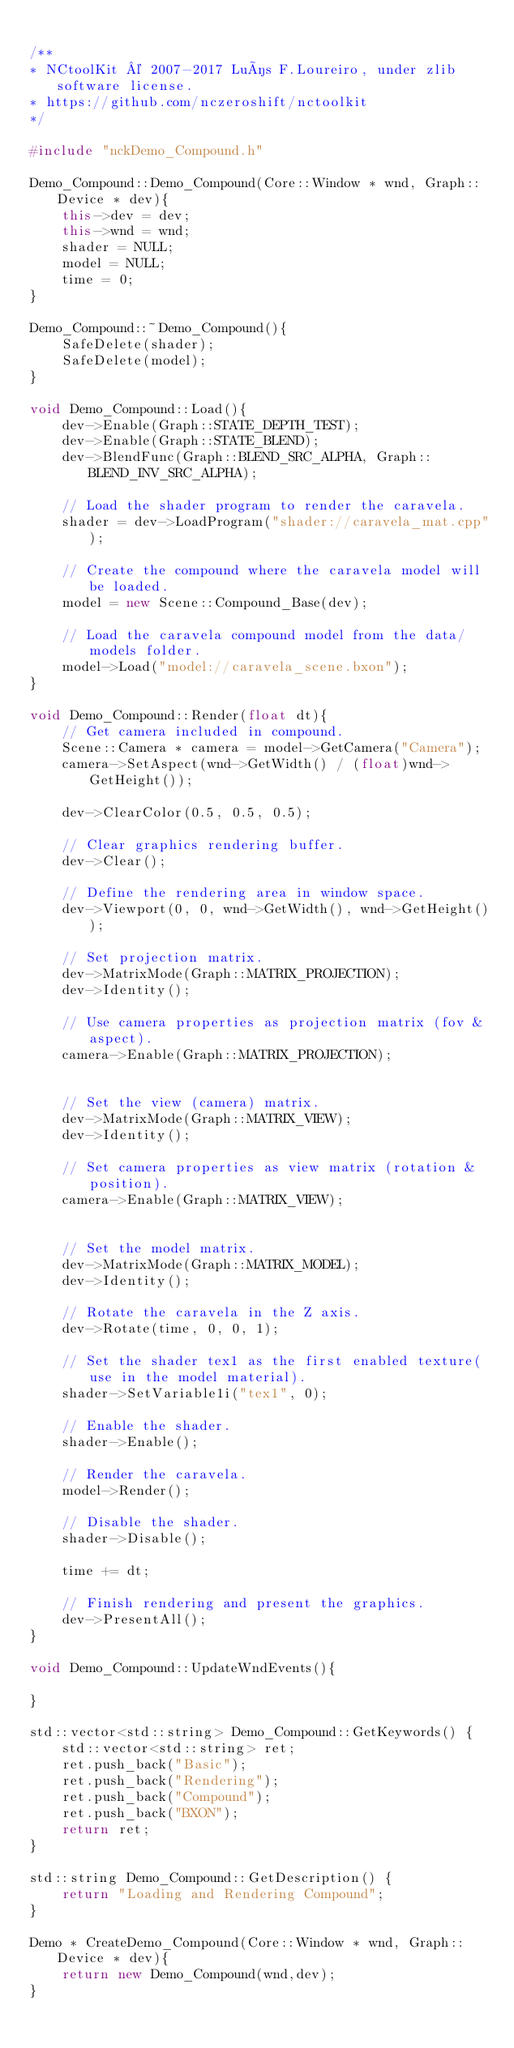Convert code to text. <code><loc_0><loc_0><loc_500><loc_500><_C++_>
/**
* NCtoolKit © 2007-2017 Luís F.Loureiro, under zlib software license.
* https://github.com/nczeroshift/nctoolkit
*/

#include "nckDemo_Compound.h"

Demo_Compound::Demo_Compound(Core::Window * wnd, Graph::Device * dev){
	this->dev = dev;
	this->wnd = wnd;
    shader = NULL;
    model = NULL;
    time = 0;
}

Demo_Compound::~Demo_Compound(){
    SafeDelete(shader);
    SafeDelete(model);
}

void Demo_Compound::Load(){
    dev->Enable(Graph::STATE_DEPTH_TEST);
    dev->Enable(Graph::STATE_BLEND);
    dev->BlendFunc(Graph::BLEND_SRC_ALPHA, Graph::BLEND_INV_SRC_ALPHA);

    // Load the shader program to render the caravela.
    shader = dev->LoadProgram("shader://caravela_mat.cpp");

    // Create the compound where the caravela model will be loaded.
    model = new Scene::Compound_Base(dev);

    // Load the caravela compound model from the data/models folder.
    model->Load("model://caravela_scene.bxon");
}

void Demo_Compound::Render(float dt){
    // Get camera included in compound.
    Scene::Camera * camera = model->GetCamera("Camera");
    camera->SetAspect(wnd->GetWidth() / (float)wnd->GetHeight());

    dev->ClearColor(0.5, 0.5, 0.5);

    // Clear graphics rendering buffer.
    dev->Clear();

    // Define the rendering area in window space.
    dev->Viewport(0, 0, wnd->GetWidth(), wnd->GetHeight());

    // Set projection matrix.
    dev->MatrixMode(Graph::MATRIX_PROJECTION);
    dev->Identity();

    // Use camera properties as projection matrix (fov & aspect).
    camera->Enable(Graph::MATRIX_PROJECTION);


    // Set the view (camera) matrix.
    dev->MatrixMode(Graph::MATRIX_VIEW);
    dev->Identity();

    // Set camera properties as view matrix (rotation & position).
    camera->Enable(Graph::MATRIX_VIEW);


    // Set the model matrix.
    dev->MatrixMode(Graph::MATRIX_MODEL);
    dev->Identity();

    // Rotate the caravela in the Z axis.
    dev->Rotate(time, 0, 0, 1);

    // Set the shader tex1 as the first enabled texture(use in the model material).
    shader->SetVariable1i("tex1", 0);

    // Enable the shader.
    shader->Enable();

    // Render the caravela.
    model->Render();

    // Disable the shader.
    shader->Disable();

    time += dt;

    // Finish rendering and present the graphics.
    dev->PresentAll();
}

void Demo_Compound::UpdateWndEvents(){
	
}

std::vector<std::string> Demo_Compound::GetKeywords() {
    std::vector<std::string> ret;
    ret.push_back("Basic");
    ret.push_back("Rendering");
    ret.push_back("Compound");
    ret.push_back("BXON");
    return ret;
}

std::string Demo_Compound::GetDescription() {
    return "Loading and Rendering Compound";
}

Demo * CreateDemo_Compound(Core::Window * wnd, Graph::Device * dev){
	return new Demo_Compound(wnd,dev);
}
</code> 